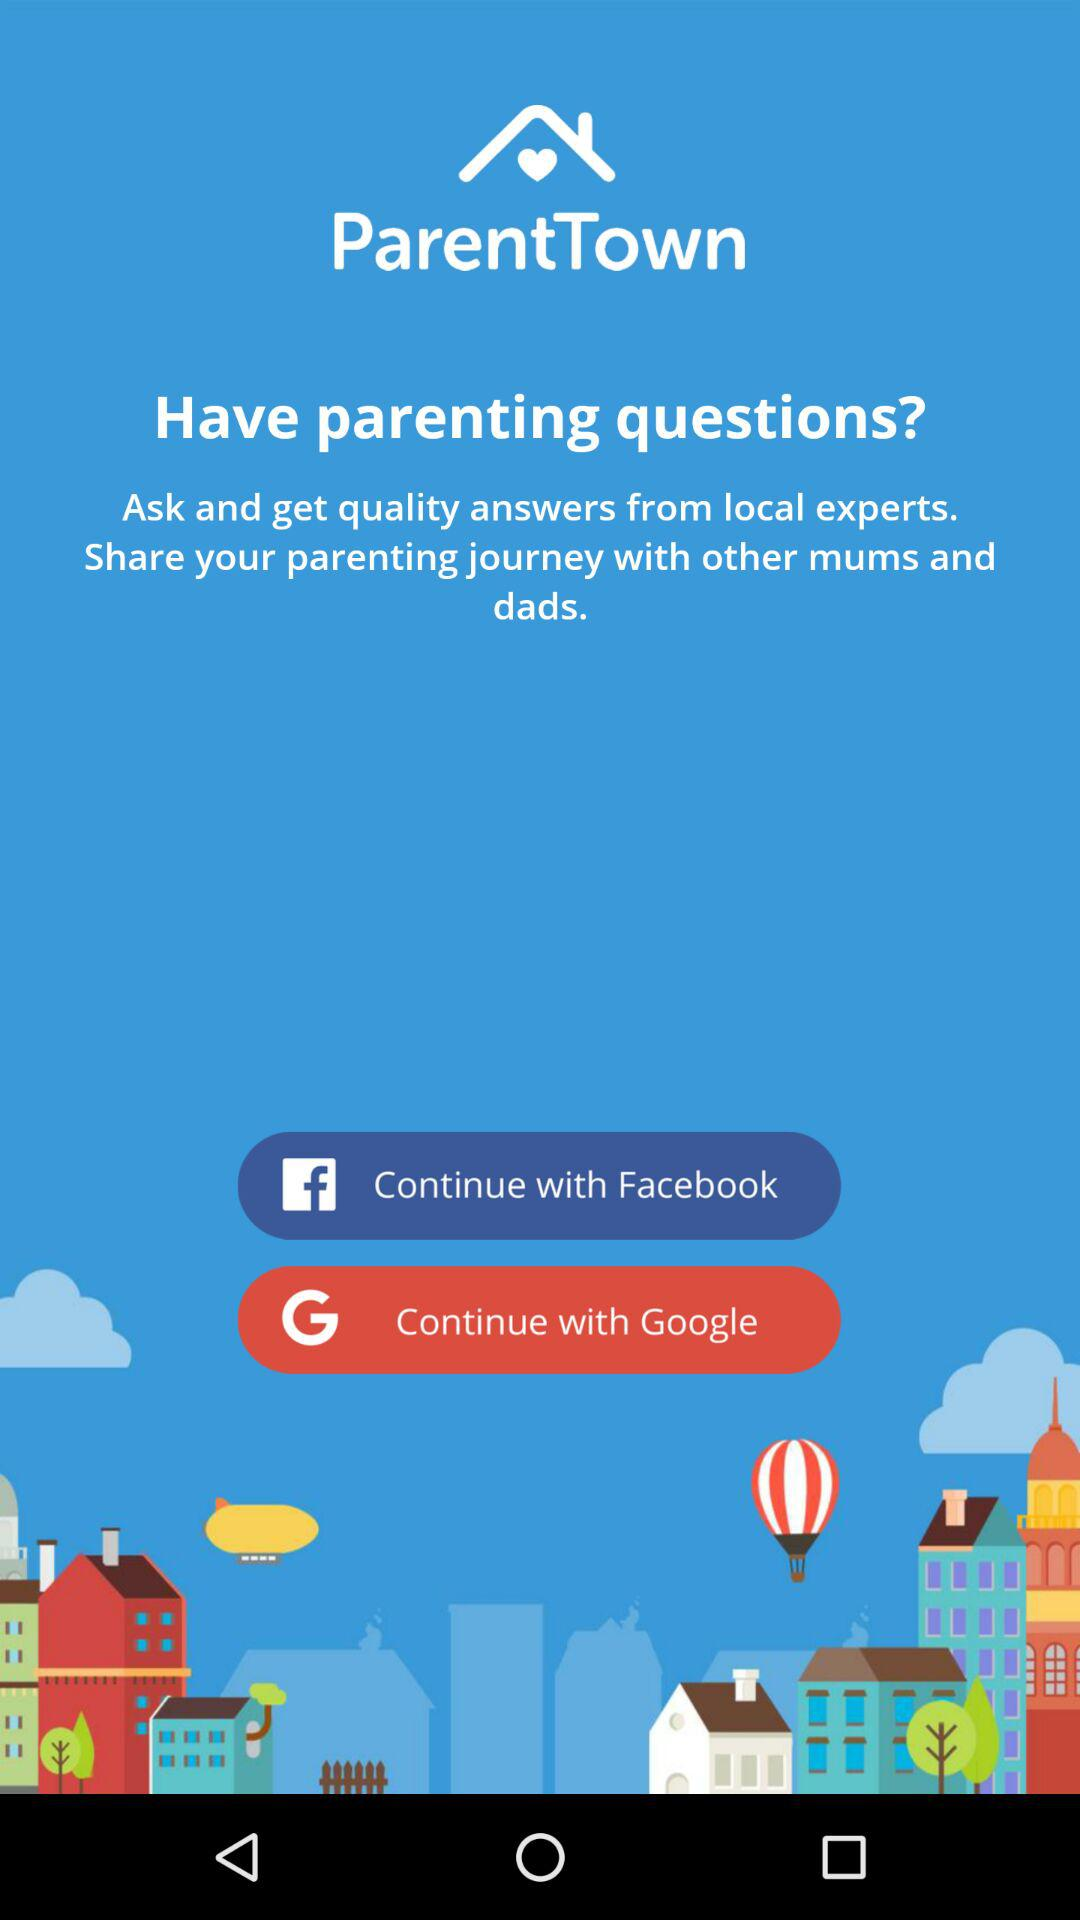What is the app name? The app name is "ParentTown". 